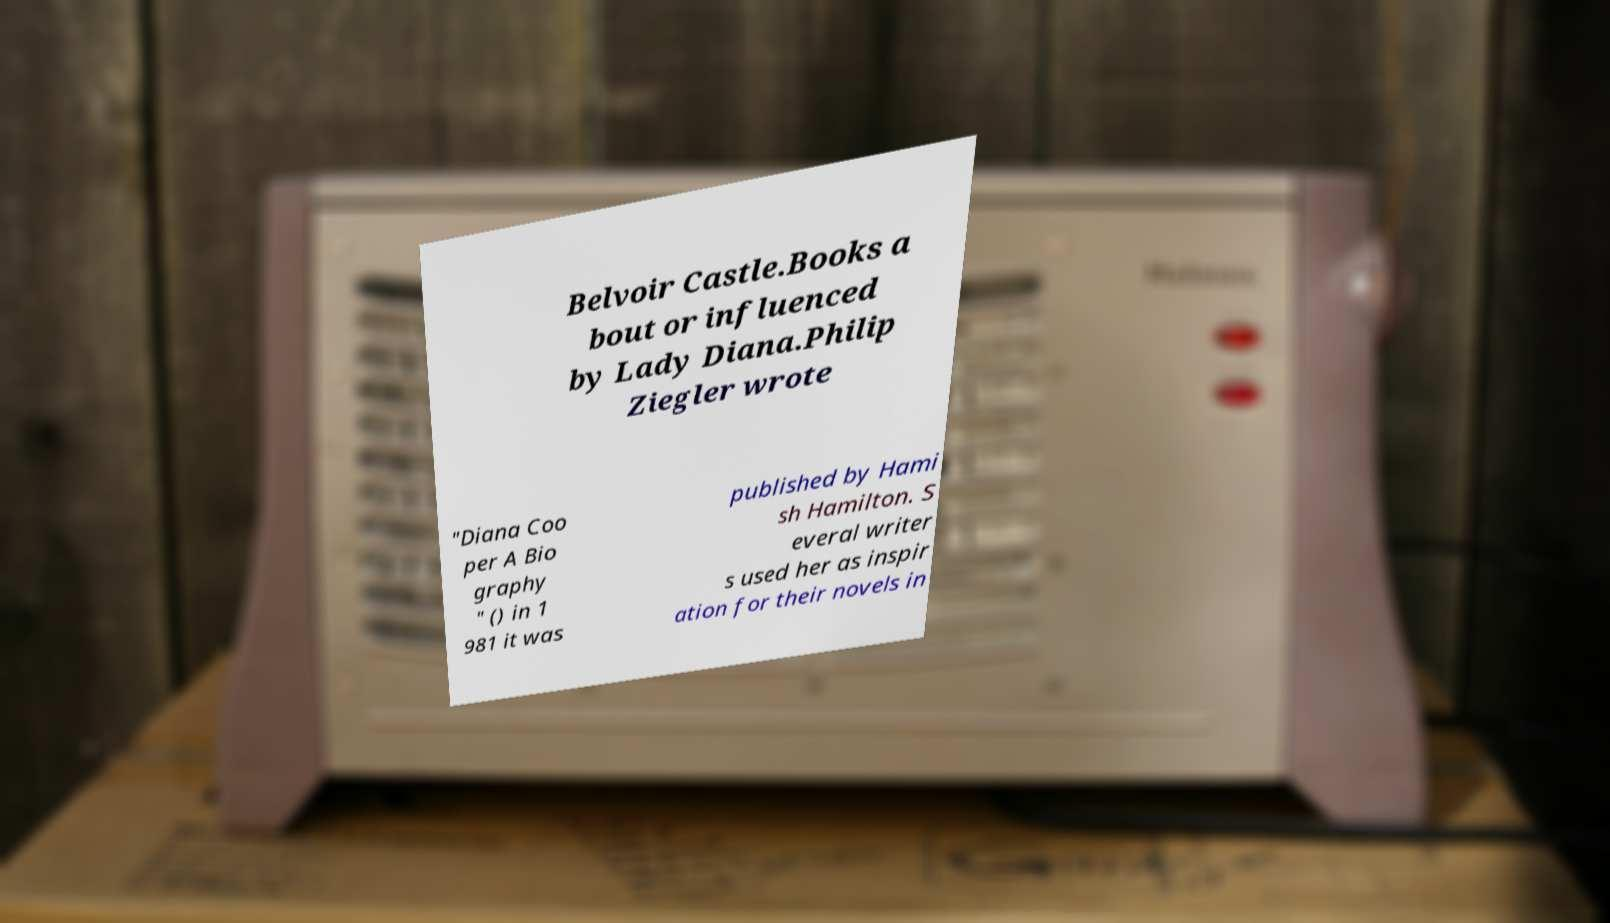There's text embedded in this image that I need extracted. Can you transcribe it verbatim? Belvoir Castle.Books a bout or influenced by Lady Diana.Philip Ziegler wrote "Diana Coo per A Bio graphy " () in 1 981 it was published by Hami sh Hamilton. S everal writer s used her as inspir ation for their novels in 